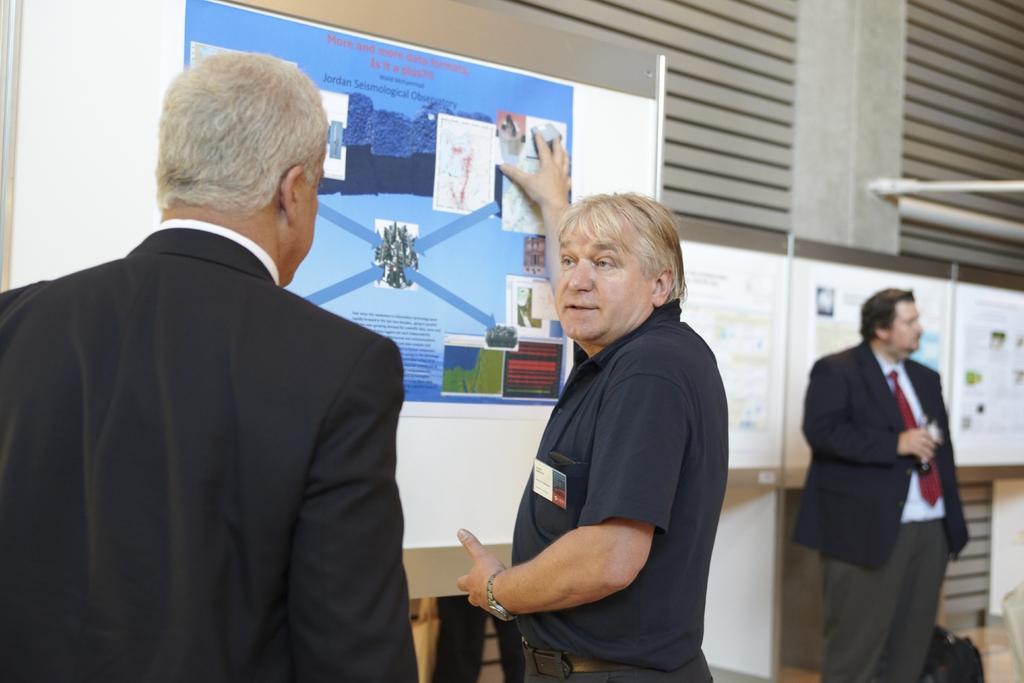How would you summarize this image in a sentence or two? There are men in the foreground area of the image and a poster in front of them and a person, bag, pillar and posters in the background. 